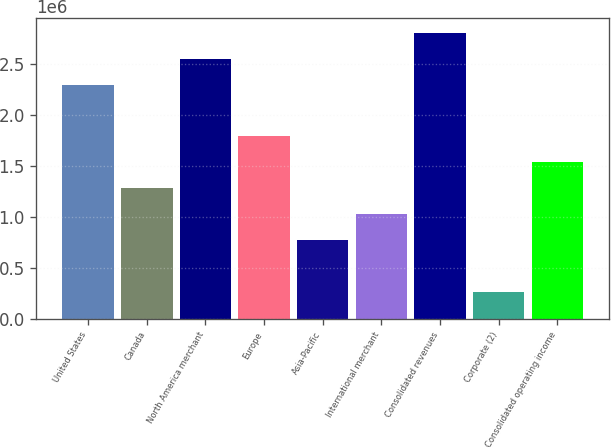<chart> <loc_0><loc_0><loc_500><loc_500><bar_chart><fcel>United States<fcel>Canada<fcel>North America merchant<fcel>Europe<fcel>Asia-Pacific<fcel>International merchant<fcel>Consolidated revenues<fcel>Corporate (2)<fcel>Consolidated operating income<nl><fcel>2.29945e+06<fcel>1.2803e+06<fcel>2.55424e+06<fcel>1.78988e+06<fcel>770730<fcel>1.02552e+06<fcel>2.80902e+06<fcel>261158<fcel>1.53509e+06<nl></chart> 